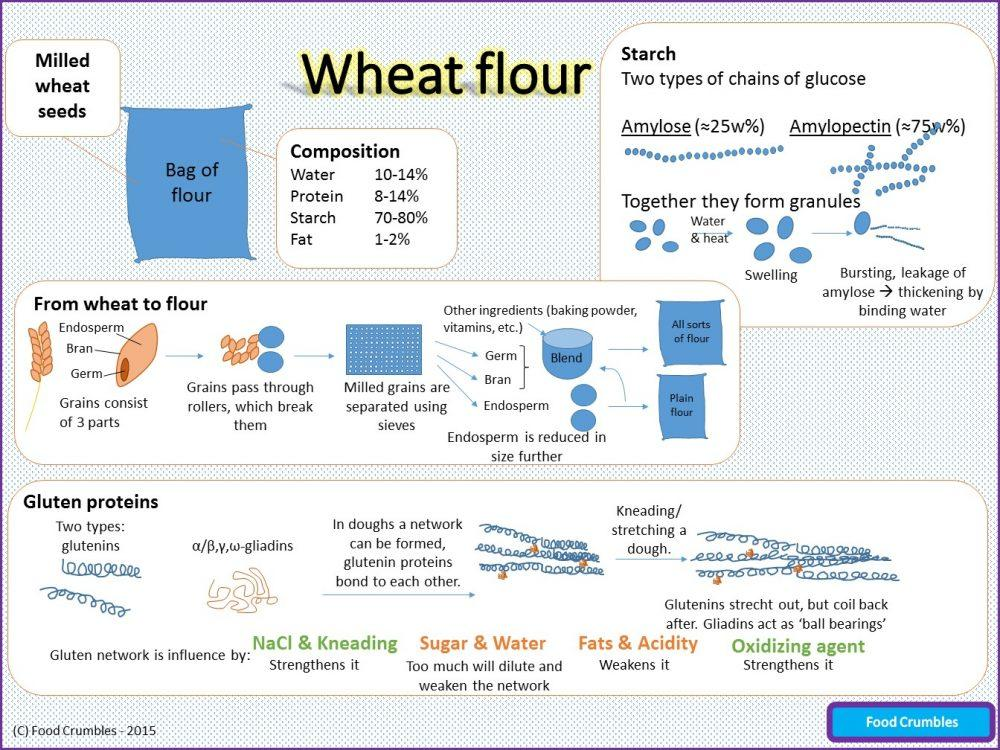Specify some key components in this picture. The gluten network is strengthened by the presence of NaCl and kneading, as well as the use of oxidizing agents. Too much sugar and water can dilute and weaken the gluten network in bread. Amylose and Amylopectin are the two primary components that form granules. The three parts of a grain are the endosperm, bran, and germ. 